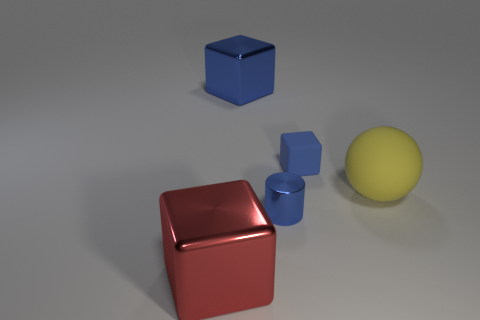There is a thing that is left of the big shiny thing on the right side of the big shiny cube in front of the small blue matte thing; what is its shape?
Make the answer very short. Cube. What is the shape of the red object that is the same size as the blue shiny block?
Your answer should be compact. Cube. There is a blue thing that is in front of the small object behind the cylinder; what number of blue metallic cylinders are on the right side of it?
Provide a short and direct response. 0. Is the number of big objects that are right of the large blue block greater than the number of big objects that are to the left of the tiny cube?
Ensure brevity in your answer.  No. How many other metallic objects are the same shape as the large red shiny object?
Your answer should be compact. 1. How many objects are large cubes behind the small blue cube or big red metal cubes that are on the left side of the tiny shiny object?
Provide a short and direct response. 2. There is a block to the right of the large metal thing that is right of the large thing in front of the big sphere; what is its material?
Offer a terse response. Rubber. There is a cube that is in front of the blue metal cylinder; does it have the same color as the matte ball?
Your response must be concise. No. There is a thing that is both on the right side of the big blue object and in front of the big matte object; what is its material?
Offer a very short reply. Metal. Is there a gray rubber ball of the same size as the cylinder?
Your answer should be compact. No. 